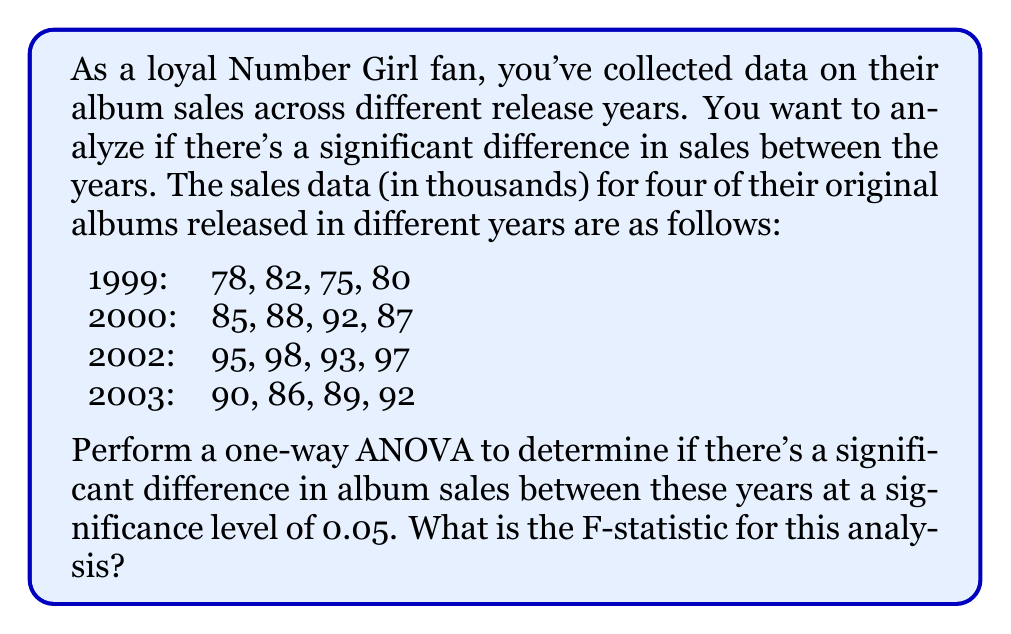Teach me how to tackle this problem. To perform a one-way ANOVA, we need to follow these steps:

1. Calculate the sum of squares between groups (SSB)
2. Calculate the sum of squares within groups (SSW)
3. Calculate the degrees of freedom (df) for between and within groups
4. Calculate the mean square between (MSB) and mean square within (MSW)
5. Calculate the F-statistic

Step 1: Calculate SSB

First, we need to find the grand mean and group means:

Grand mean: $\bar{X} = \frac{1307}{16} = 81.6875$

Group means:
1999: $\bar{X}_1 = 78.75$
2000: $\bar{X}_2 = 88$
2002: $\bar{X}_3 = 95.75$
2003: $\bar{X}_4 = 89.25$

Now, we can calculate SSB:

$$SSB = \sum_{i=1}^{k} n_i(\bar{X}_i - \bar{X})^2$$

Where $k$ is the number of groups and $n_i$ is the number of observations in each group.

$$SSB = 4(78.75 - 81.6875)^2 + 4(88 - 81.6875)^2 + 4(95.75 - 81.6875)^2 + 4(89.25 - 81.6875)^2$$
$$SSB = 735.84375$$

Step 2: Calculate SSW

$$SSW = \sum_{i=1}^{k} \sum_{j=1}^{n_i} (X_{ij} - \bar{X}_i)^2$$

1999: $(78-78.75)^2 + (82-78.75)^2 + (75-78.75)^2 + (80-78.75)^2 = 26.75$
2000: $(85-88)^2 + (88-88)^2 + (92-88)^2 + (87-88)^2 = 26$
2002: $(95-95.75)^2 + (98-95.75)^2 + (93-95.75)^2 + (97-95.75)^2 = 10.75$
2003: $(90-89.25)^2 + (86-89.25)^2 + (89-89.25)^2 + (92-89.25)^2 = 18$

$$SSW = 26.75 + 26 + 10.75 + 18 = 81.5$$

Step 3: Calculate degrees of freedom

df between = k - 1 = 4 - 1 = 3
df within = N - k = 16 - 4 = 12

Step 4: Calculate MSB and MSW

$$MSB = \frac{SSB}{df_{between}} = \frac{735.84375}{3} = 245.28125$$
$$MSW = \frac{SSW}{df_{within}} = \frac{81.5}{12} = 6.79167$$

Step 5: Calculate F-statistic

$$F = \frac{MSB}{MSW} = \frac{245.28125}{6.79167} = 36.11$$
Answer: The F-statistic for this analysis is 36.11. 